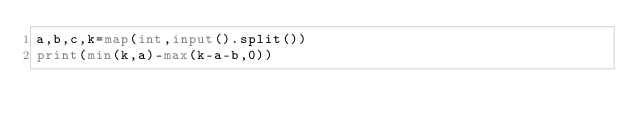<code> <loc_0><loc_0><loc_500><loc_500><_Python_>a,b,c,k=map(int,input().split())
print(min(k,a)-max(k-a-b,0))</code> 